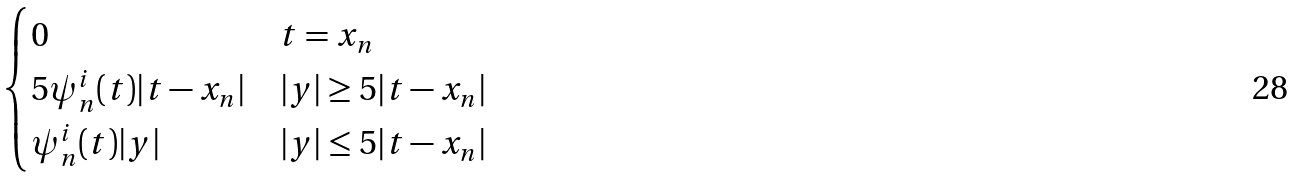<formula> <loc_0><loc_0><loc_500><loc_500>\begin{cases} 0 & t = x _ { n } \\ 5 \psi _ { n } ^ { i } ( t ) | t - x _ { n } | & | y | \geq 5 | t - x _ { n } | \\ \psi _ { n } ^ { i } ( t ) | y | & | y | \leq 5 | t - x _ { n } | \end{cases}</formula> 